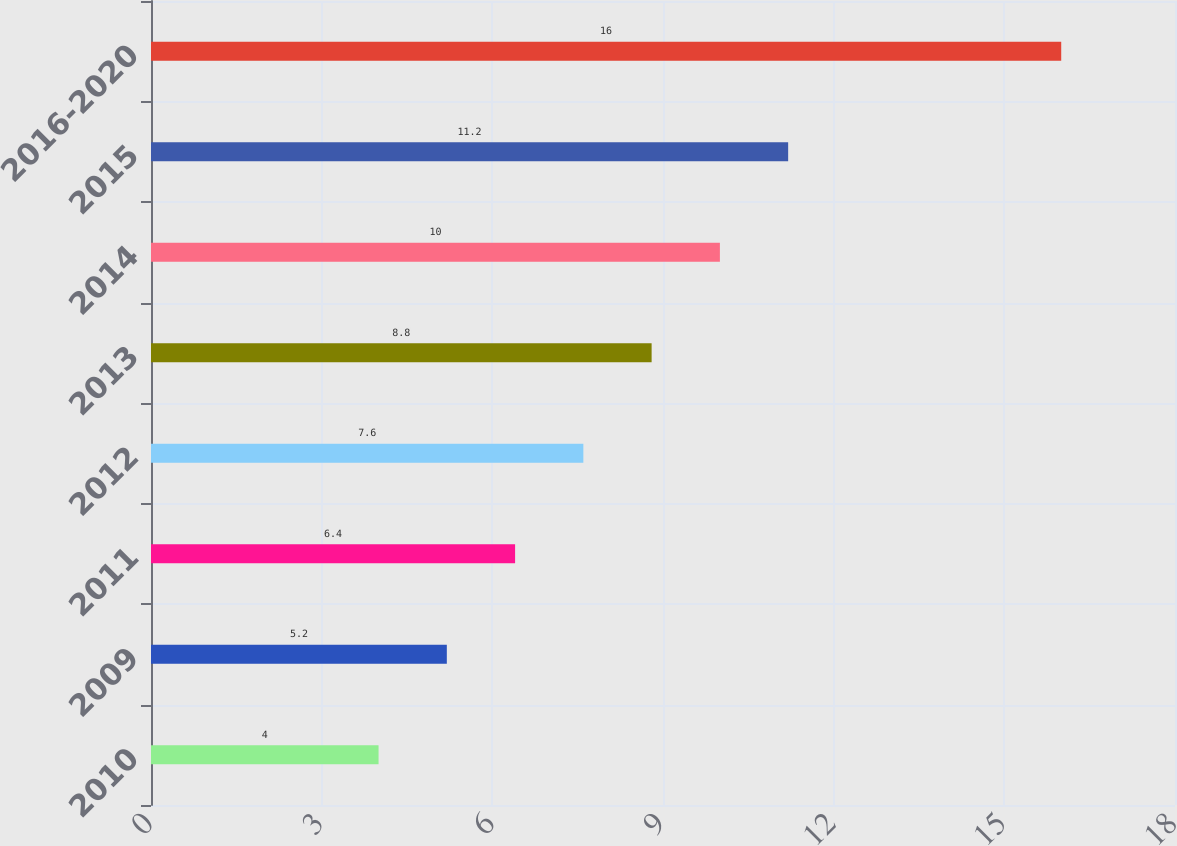Convert chart. <chart><loc_0><loc_0><loc_500><loc_500><bar_chart><fcel>2010<fcel>2009<fcel>2011<fcel>2012<fcel>2013<fcel>2014<fcel>2015<fcel>2016-2020<nl><fcel>4<fcel>5.2<fcel>6.4<fcel>7.6<fcel>8.8<fcel>10<fcel>11.2<fcel>16<nl></chart> 